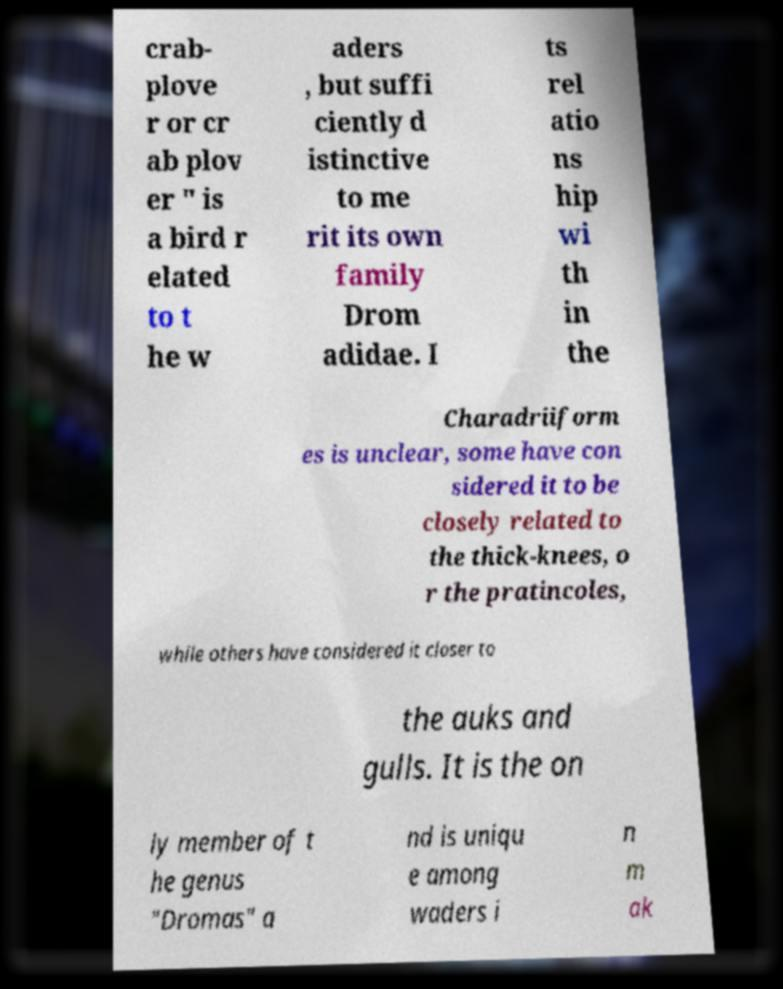Could you extract and type out the text from this image? crab- plove r or cr ab plov er " is a bird r elated to t he w aders , but suffi ciently d istinctive to me rit its own family Drom adidae. I ts rel atio ns hip wi th in the Charadriiform es is unclear, some have con sidered it to be closely related to the thick-knees, o r the pratincoles, while others have considered it closer to the auks and gulls. It is the on ly member of t he genus "Dromas" a nd is uniqu e among waders i n m ak 